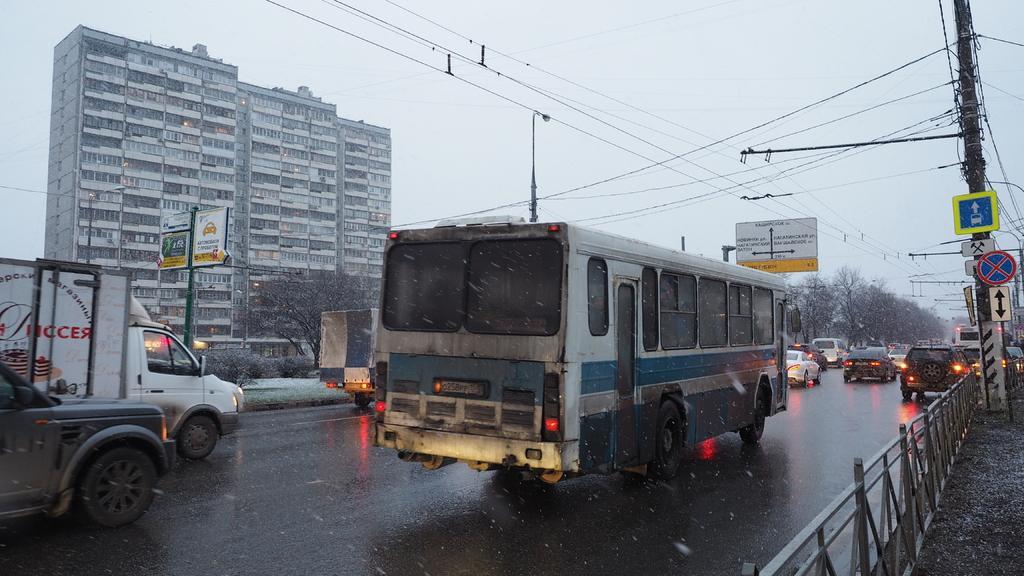Describe this image in one or two sentences. In this image we can see there are many vehicles moving on the road. On the right side of the image there is a railing and a utility pole. In the background there is a building, trees and sky. 